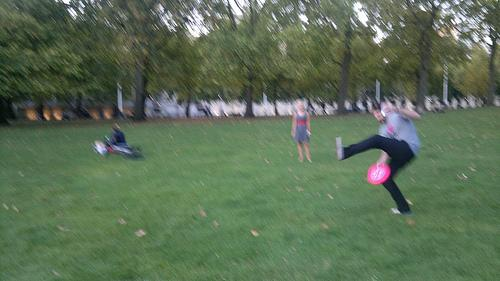What does the woman in the image wear and where is she standing? The woman is wearing a blue top and skirt with a pink middle, red belt, and standing in a field. Count the number of people in the image and describe their actions. There are four people in the image; three of them are playing with a frisbee, and one woman is standing in the field. What is the color of the man's pants holding the frisbee? The man is wearing black pants. Describe the physical appearance of the woman in the image. The woman has blond hair and wears a blue dress with a pink middle and a red belt. Evaluate the sentiment and atmosphere of the image. The sentiment is positive, as it depicts people enjoying a friendly game of frisbee in a beautiful, green field setting. What is the color of the frisbee and what is a noticeable design feature on it? The frisbee is pink in color, and it has a white design on the top. What is the main activity happening in the image, and how many people are involved in it? The main activity is playing with a frisbee, and three people are involved in it. Analyze the image and describe the setting. The setting is a green park with people playing frisbee and a woman standing in the field, with trees at the edge. What is the color and design of the man's shirt holding the frisbee? The man is wearing a gray shirt with a red and gray design on it. Briefly describe the scene in this image. Three people are playing with a frisbee on a green field, while a woman in a blue dress stands nearby and some trees are present in the background. 